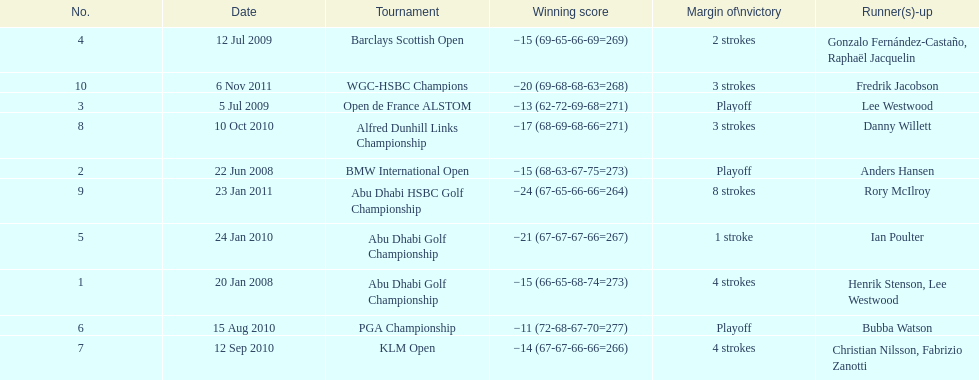What were all of the tournaments martin played in? Abu Dhabi Golf Championship, BMW International Open, Open de France ALSTOM, Barclays Scottish Open, Abu Dhabi Golf Championship, PGA Championship, KLM Open, Alfred Dunhill Links Championship, Abu Dhabi HSBC Golf Championship, WGC-HSBC Champions. And how many strokes did he score? −15 (66-65-68-74=273), −15 (68-63-67-75=273), −13 (62-72-69-68=271), −15 (69-65-66-69=269), −21 (67-67-67-66=267), −11 (72-68-67-70=277), −14 (67-67-66-66=266), −17 (68-69-68-66=271), −24 (67-65-66-66=264), −20 (69-68-68-63=268). What about during barclays and klm? −15 (69-65-66-69=269), −14 (67-67-66-66=266). How many more were scored in klm? 2 strokes. 